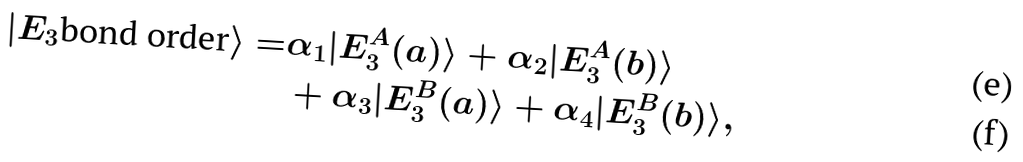<formula> <loc_0><loc_0><loc_500><loc_500>| E _ { 3 } \text {bond order} \rangle = & \alpha _ { 1 } | E _ { 3 } ^ { A } ( a ) \rangle + \alpha _ { 2 } | E _ { 3 } ^ { A } ( b ) \rangle \\ & + \alpha _ { 3 } | E _ { 3 } ^ { B } ( a ) \rangle + \alpha _ { 4 } | E _ { 3 } ^ { B } ( b ) \rangle ,</formula> 